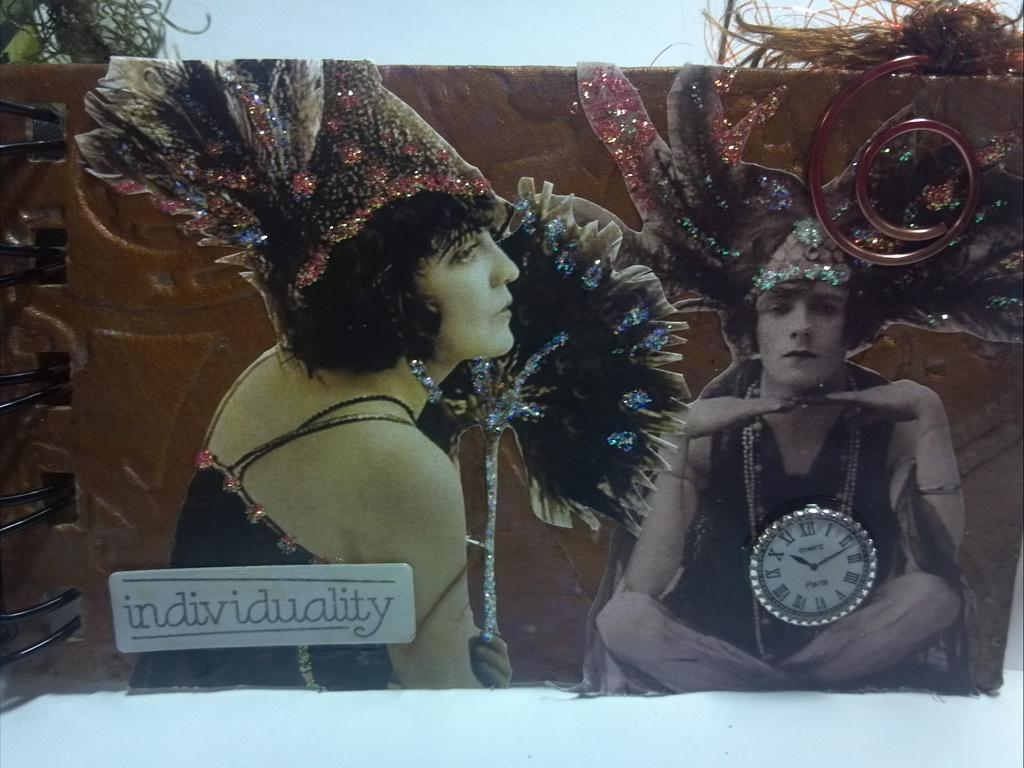<image>
Share a concise interpretation of the image provided. Sign that shows two people and the word "individuality" under them. 